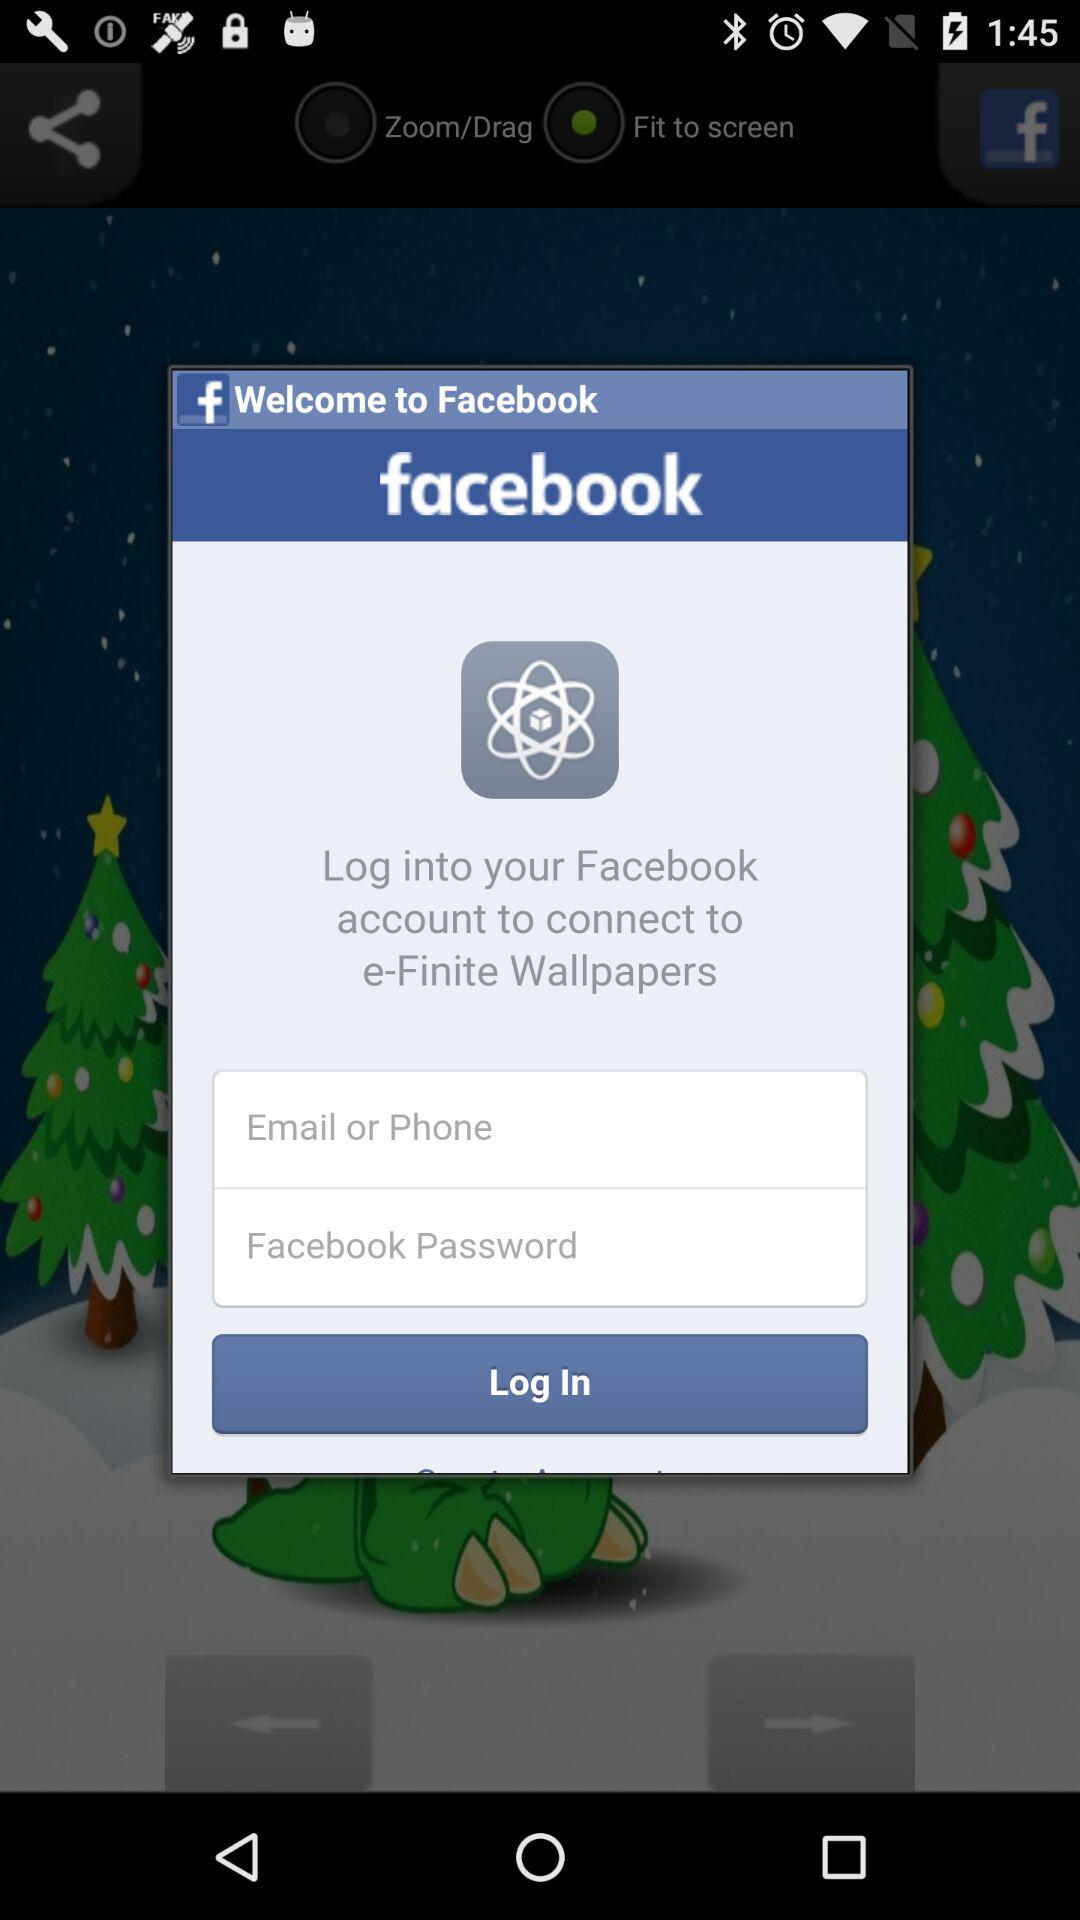What is the entered password?
When the provided information is insufficient, respond with <no answer>. <no answer> 